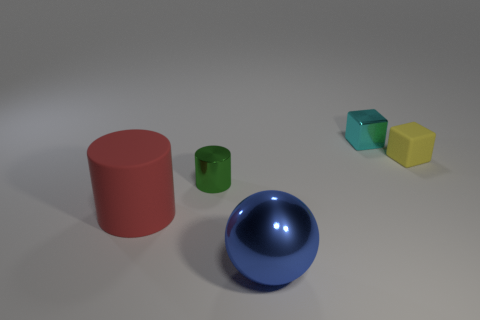Is there any other thing that is the same shape as the big blue thing?
Offer a terse response. No. Do the red matte cylinder and the shiny block have the same size?
Offer a terse response. No. The big thing that is the same material as the tiny yellow object is what color?
Give a very brief answer. Red. Are there fewer tiny things on the left side of the yellow matte block than things that are behind the blue metallic object?
Your response must be concise. Yes. How many small things are the same color as the big cylinder?
Give a very brief answer. 0. What number of tiny metal objects are both behind the small yellow cube and on the left side of the sphere?
Ensure brevity in your answer.  0. There is a cylinder right of the matte object that is in front of the matte block; what is its material?
Your answer should be very brief. Metal. Is there another large thing that has the same material as the cyan thing?
Ensure brevity in your answer.  Yes. What is the material of the red cylinder that is the same size as the blue object?
Ensure brevity in your answer.  Rubber. There is a metal thing that is behind the tiny metal thing in front of the cyan metal thing that is right of the sphere; how big is it?
Your response must be concise. Small. 